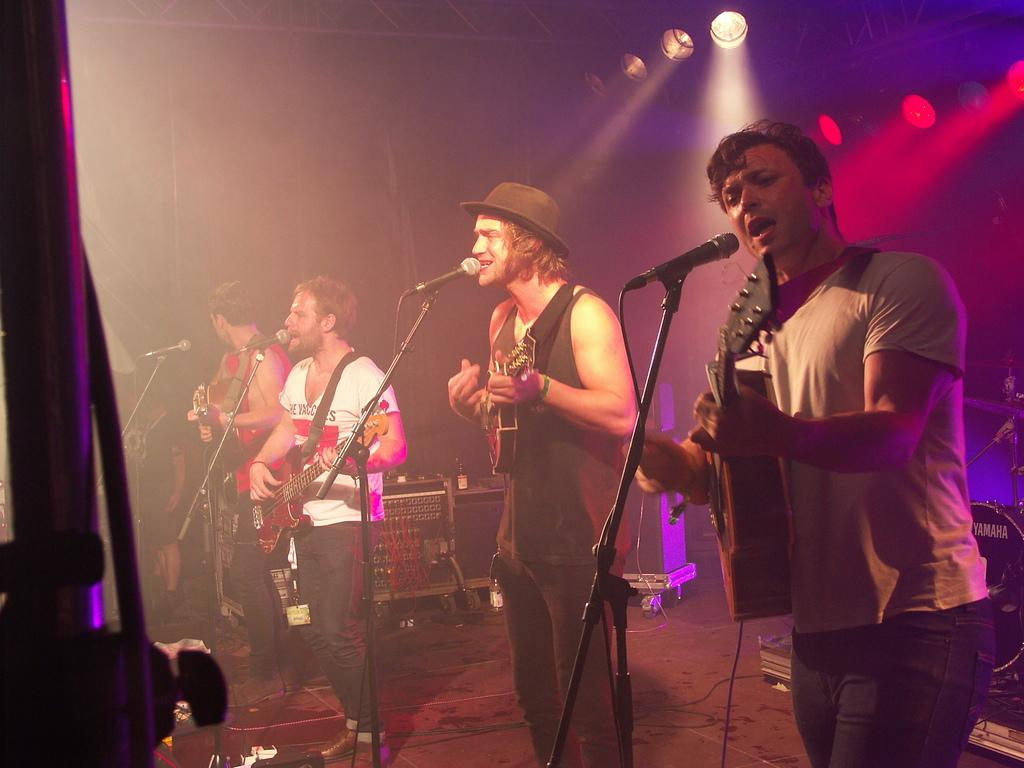What is happening in the image involving the group of people? In the image, some people in the group are playing guitar, and some are singing. What objects are related to the singing activity in the image? There is a microphone and a microphone stand in the image. What can be seen in the background that might indicate a performance setting? There are lights visible in the image. What type of cherry is being used as a prop in the image? There is no cherry present in the image. How does the behavior of the cabbage affect the performance in the image? There is no cabbage present in the image, so its behavior cannot affect the performance. 